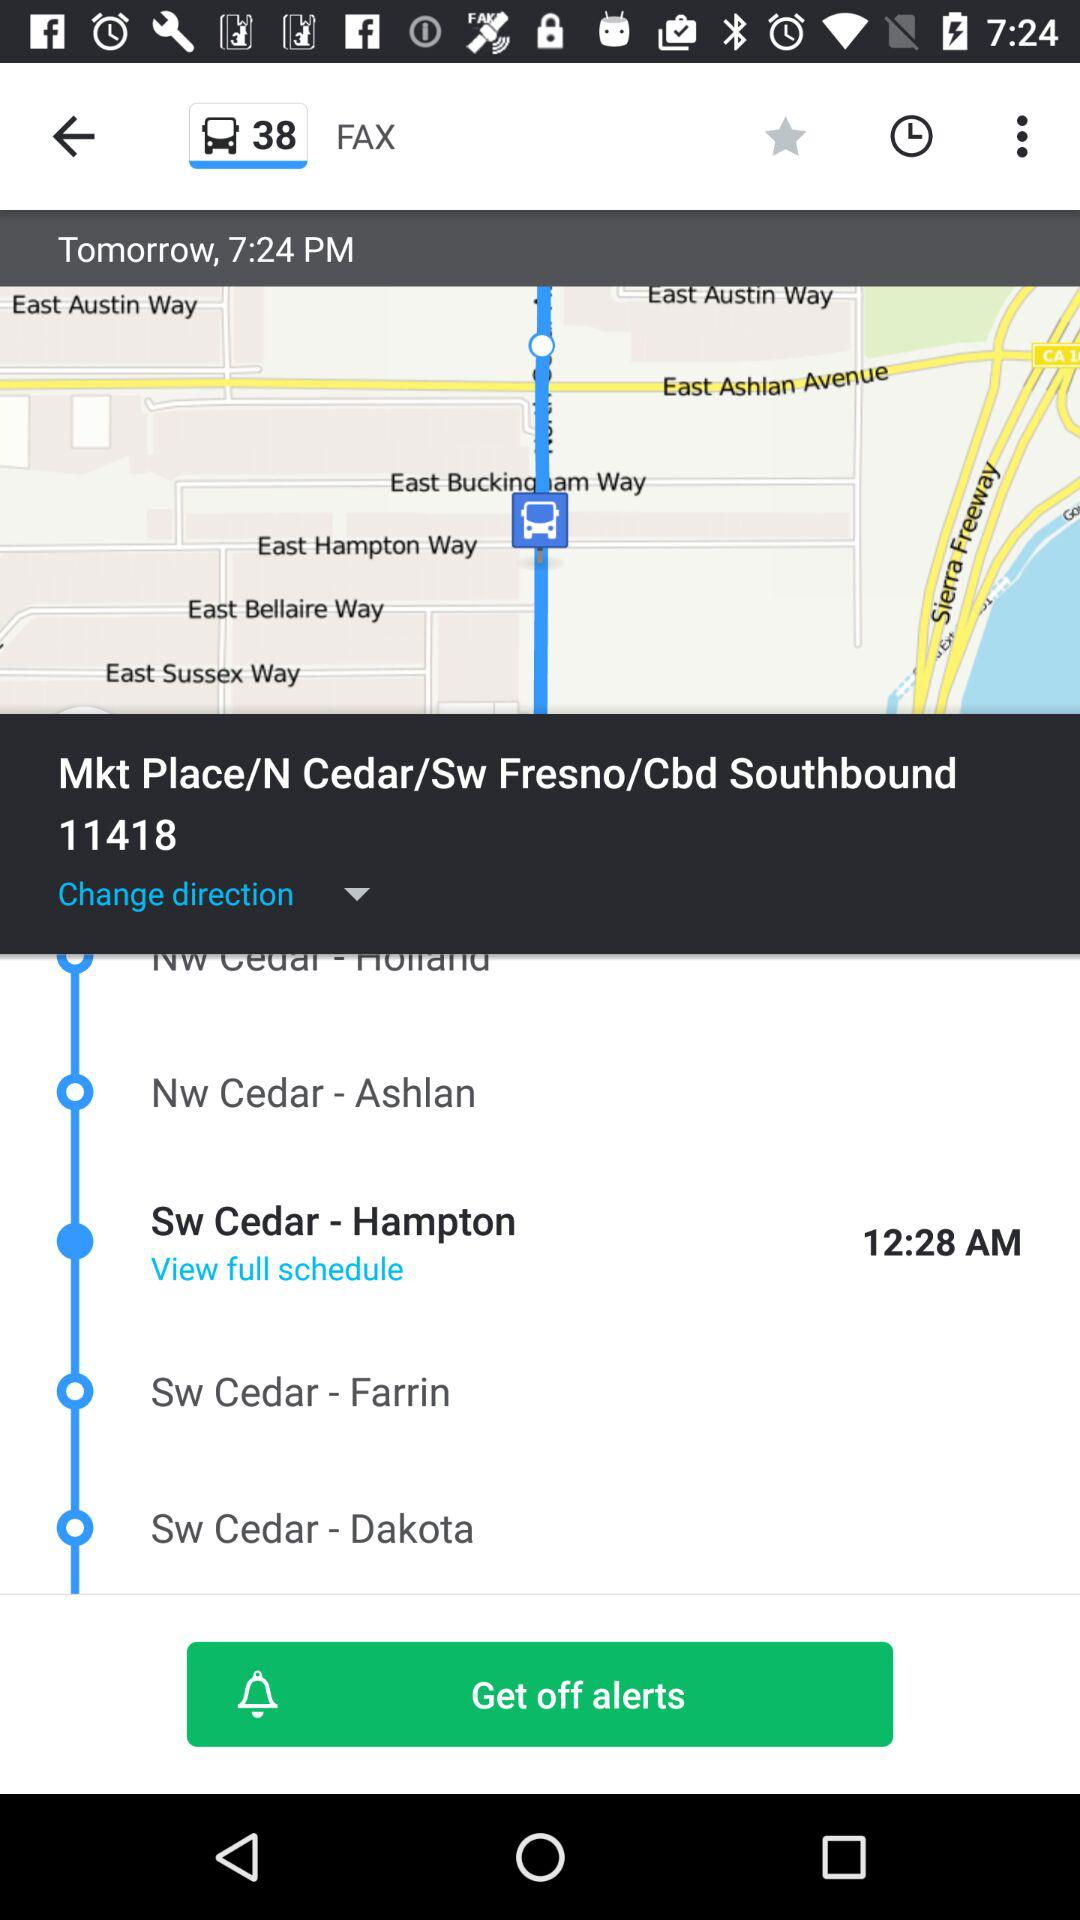What is the stop address at 12:28 am? The stop address at 12:28 am is Sw Cedar-Hampton. 